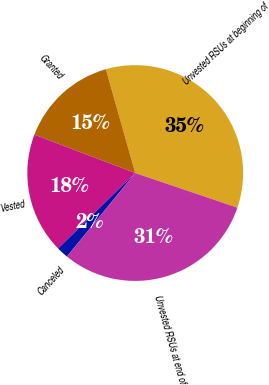Convert chart to OTSL. <chart><loc_0><loc_0><loc_500><loc_500><pie_chart><fcel>Unvested RSUs at beginning of<fcel>Granted<fcel>Vested<fcel>Canceled<fcel>Unvested RSUs at end of<nl><fcel>34.59%<fcel>14.83%<fcel>18.11%<fcel>1.76%<fcel>30.71%<nl></chart> 